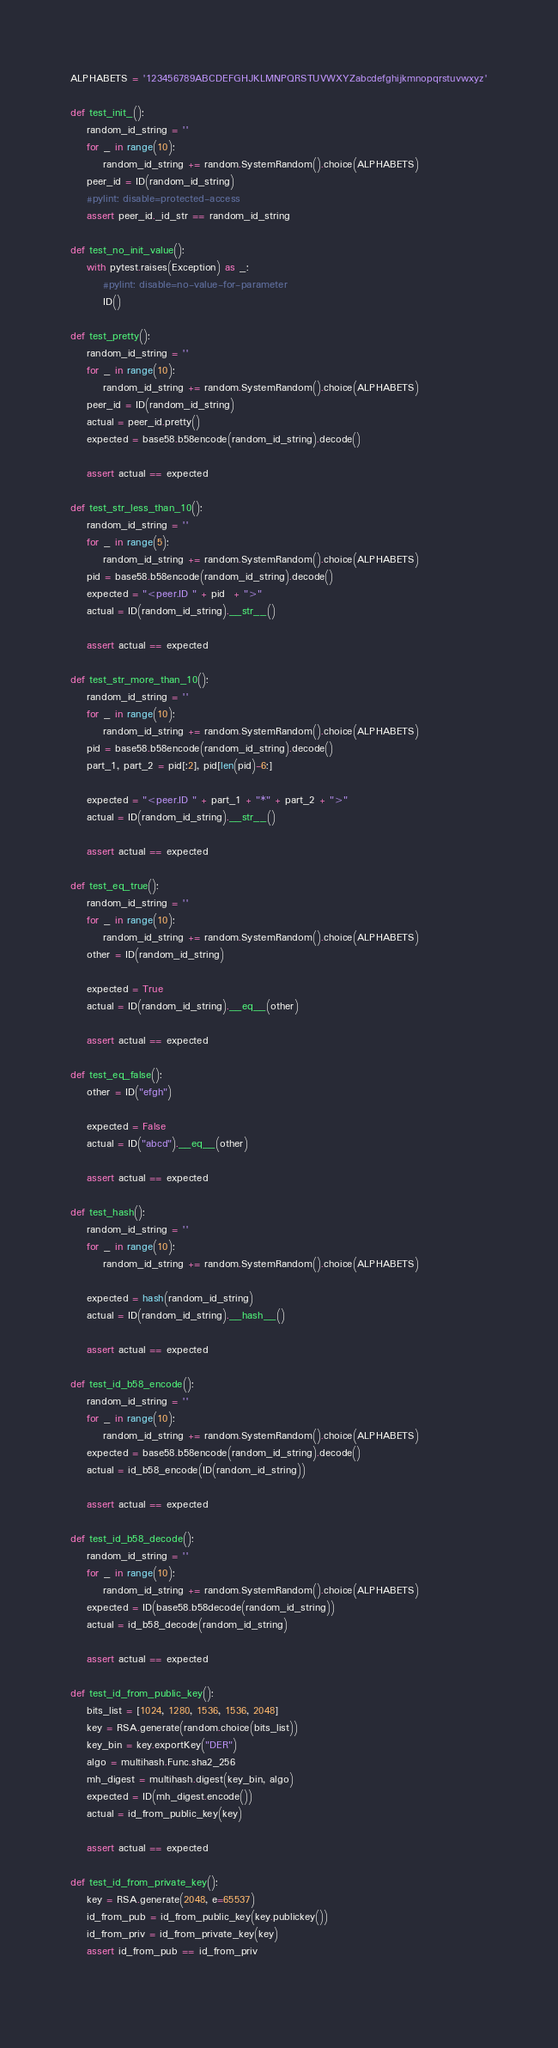Convert code to text. <code><loc_0><loc_0><loc_500><loc_500><_Python_>
ALPHABETS = '123456789ABCDEFGHJKLMNPQRSTUVWXYZabcdefghijkmnopqrstuvwxyz'

def test_init_():
    random_id_string = ''
    for _ in range(10):
        random_id_string += random.SystemRandom().choice(ALPHABETS)
    peer_id = ID(random_id_string)
    #pylint: disable=protected-access
    assert peer_id._id_str == random_id_string

def test_no_init_value():
    with pytest.raises(Exception) as _:
        #pylint: disable=no-value-for-parameter
        ID()

def test_pretty():
    random_id_string = ''
    for _ in range(10):
        random_id_string += random.SystemRandom().choice(ALPHABETS)
    peer_id = ID(random_id_string)
    actual = peer_id.pretty()
    expected = base58.b58encode(random_id_string).decode()

    assert actual == expected

def test_str_less_than_10():
    random_id_string = ''
    for _ in range(5):
        random_id_string += random.SystemRandom().choice(ALPHABETS)
    pid = base58.b58encode(random_id_string).decode()
    expected = "<peer.ID " + pid  + ">"
    actual = ID(random_id_string).__str__()

    assert actual == expected

def test_str_more_than_10():
    random_id_string = ''
    for _ in range(10):
        random_id_string += random.SystemRandom().choice(ALPHABETS)
    pid = base58.b58encode(random_id_string).decode()
    part_1, part_2 = pid[:2], pid[len(pid)-6:]

    expected = "<peer.ID " + part_1 + "*" + part_2 + ">"
    actual = ID(random_id_string).__str__()

    assert actual == expected

def test_eq_true():
    random_id_string = ''
    for _ in range(10):
        random_id_string += random.SystemRandom().choice(ALPHABETS)
    other = ID(random_id_string)

    expected = True
    actual = ID(random_id_string).__eq__(other)

    assert actual == expected

def test_eq_false():
    other = ID("efgh")

    expected = False
    actual = ID("abcd").__eq__(other)

    assert actual == expected

def test_hash():
    random_id_string = ''
    for _ in range(10):
        random_id_string += random.SystemRandom().choice(ALPHABETS)

    expected = hash(random_id_string)
    actual = ID(random_id_string).__hash__()

    assert actual == expected

def test_id_b58_encode():
    random_id_string = ''
    for _ in range(10):
        random_id_string += random.SystemRandom().choice(ALPHABETS)
    expected = base58.b58encode(random_id_string).decode()
    actual = id_b58_encode(ID(random_id_string))

    assert actual == expected

def test_id_b58_decode():
    random_id_string = ''
    for _ in range(10):
        random_id_string += random.SystemRandom().choice(ALPHABETS)
    expected = ID(base58.b58decode(random_id_string))
    actual = id_b58_decode(random_id_string)

    assert actual == expected

def test_id_from_public_key():
    bits_list = [1024, 1280, 1536, 1536, 2048]
    key = RSA.generate(random.choice(bits_list))
    key_bin = key.exportKey("DER")
    algo = multihash.Func.sha2_256
    mh_digest = multihash.digest(key_bin, algo)
    expected = ID(mh_digest.encode())
    actual = id_from_public_key(key)

    assert actual == expected

def test_id_from_private_key():
    key = RSA.generate(2048, e=65537)
    id_from_pub = id_from_public_key(key.publickey())
    id_from_priv = id_from_private_key(key)
    assert id_from_pub == id_from_priv
    </code> 